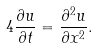Convert formula to latex. <formula><loc_0><loc_0><loc_500><loc_500>4 \frac { \partial u } { \partial t } = \frac { \partial ^ { 2 } u } { \partial x ^ { 2 } } .</formula> 